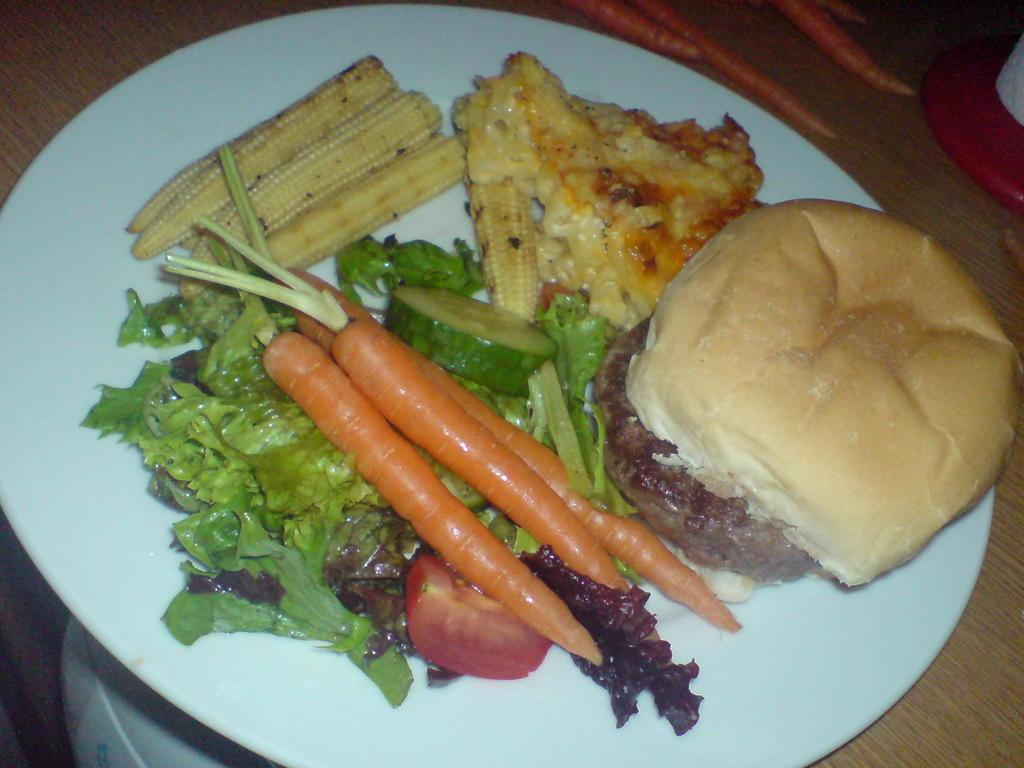What is on the plate that is visible in the image? There is food in a plate in the image. Where is the plate located in the image? The plate is on a wooden platform. What type of vegetable can be seen in the background of the image? Carrots are present in the background of the image. Can you describe the unspecified object in the background of the image? Unfortunately, the facts provided do not give enough information to describe the unspecified object in the background of the image. What type of game is being played in the image? There is no game being played in the image; it features a plate of food on a wooden platform with carrots and an unspecified object in the background. 